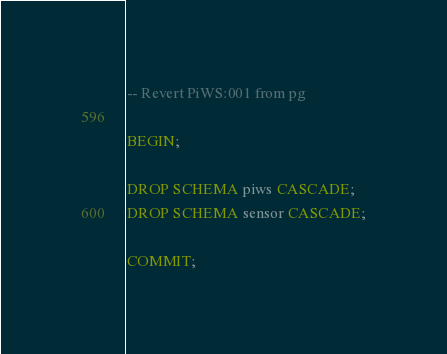Convert code to text. <code><loc_0><loc_0><loc_500><loc_500><_SQL_>-- Revert PiWS:001 from pg

BEGIN;

DROP SCHEMA piws CASCADE;
DROP SCHEMA sensor CASCADE;

COMMIT;
</code> 